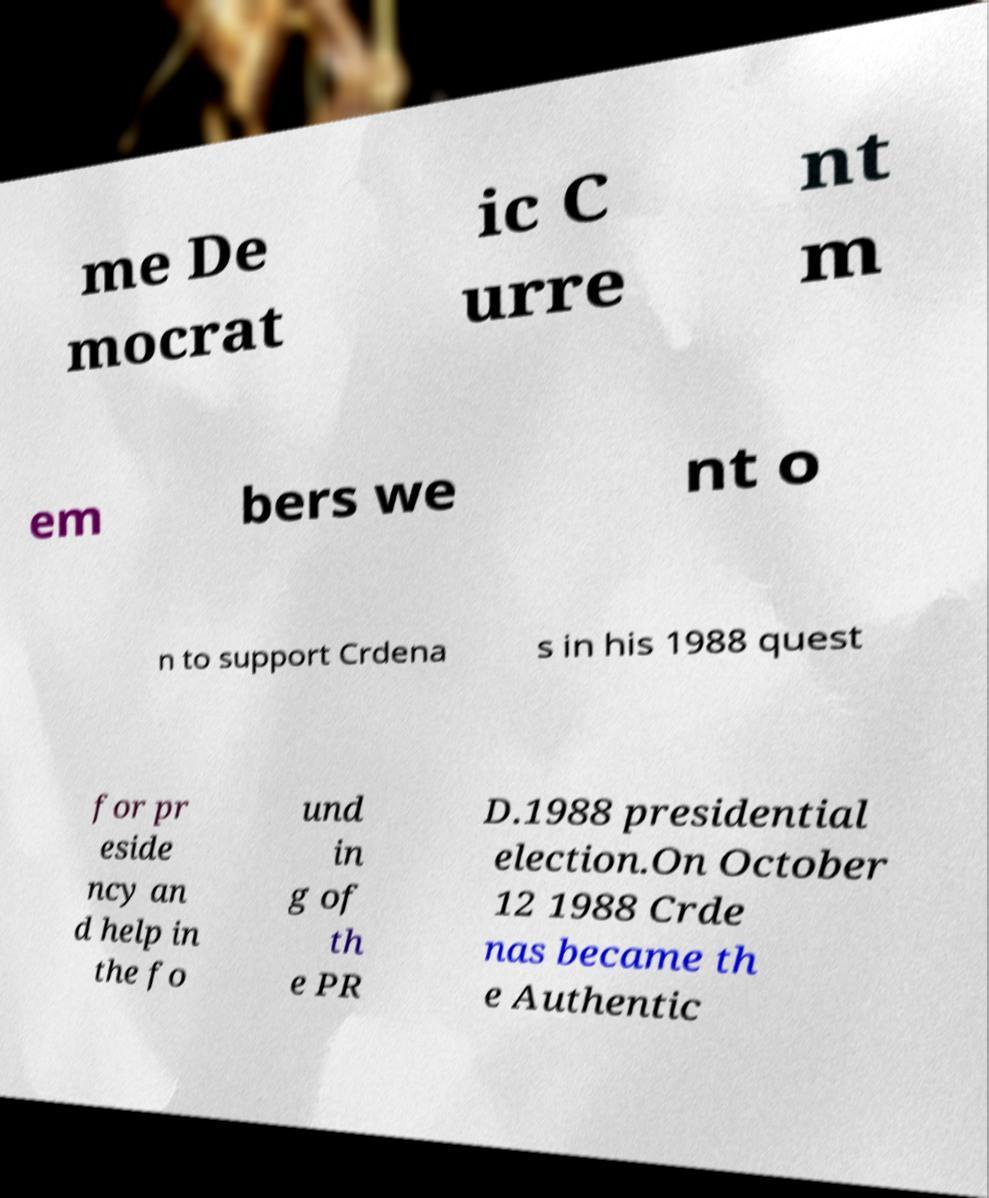Can you read and provide the text displayed in the image?This photo seems to have some interesting text. Can you extract and type it out for me? me De mocrat ic C urre nt m em bers we nt o n to support Crdena s in his 1988 quest for pr eside ncy an d help in the fo und in g of th e PR D.1988 presidential election.On October 12 1988 Crde nas became th e Authentic 